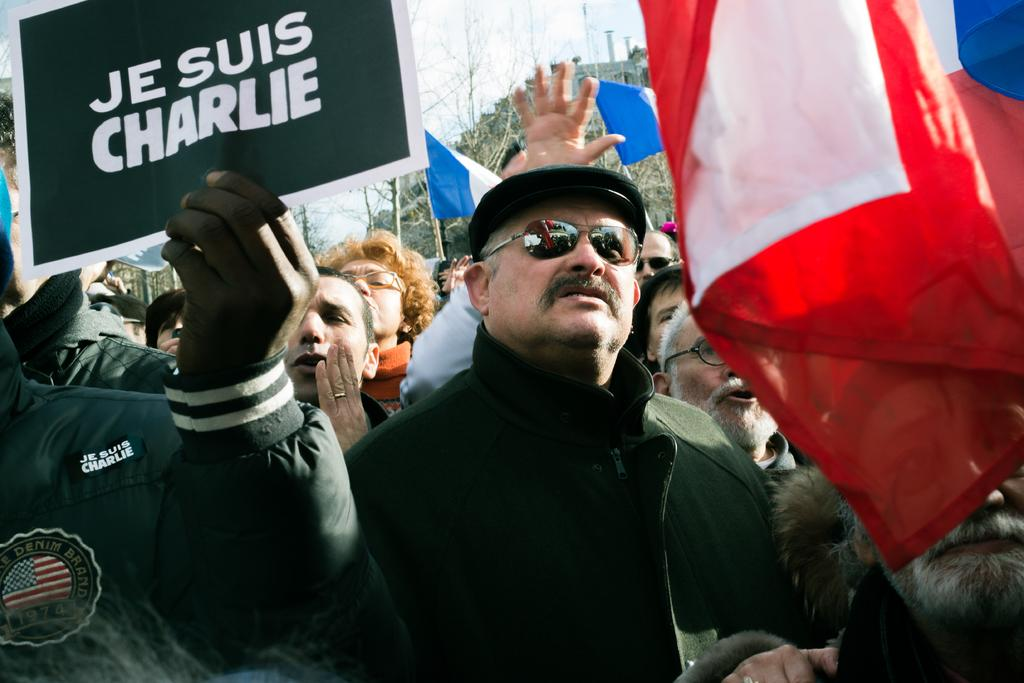Who is present in the image? There are people in the image. What are the people doing in the image? The people are protesting on a road. What are the protesters holding in the image? The protesters are holding flags and posters. What can be seen in the background of the image? There are trees and the sky visible in the background of the image. Where is the coach parked in the image? There is no coach present in the image. What type of home can be seen in the background of the image? There is no home visible in the background of the image. 